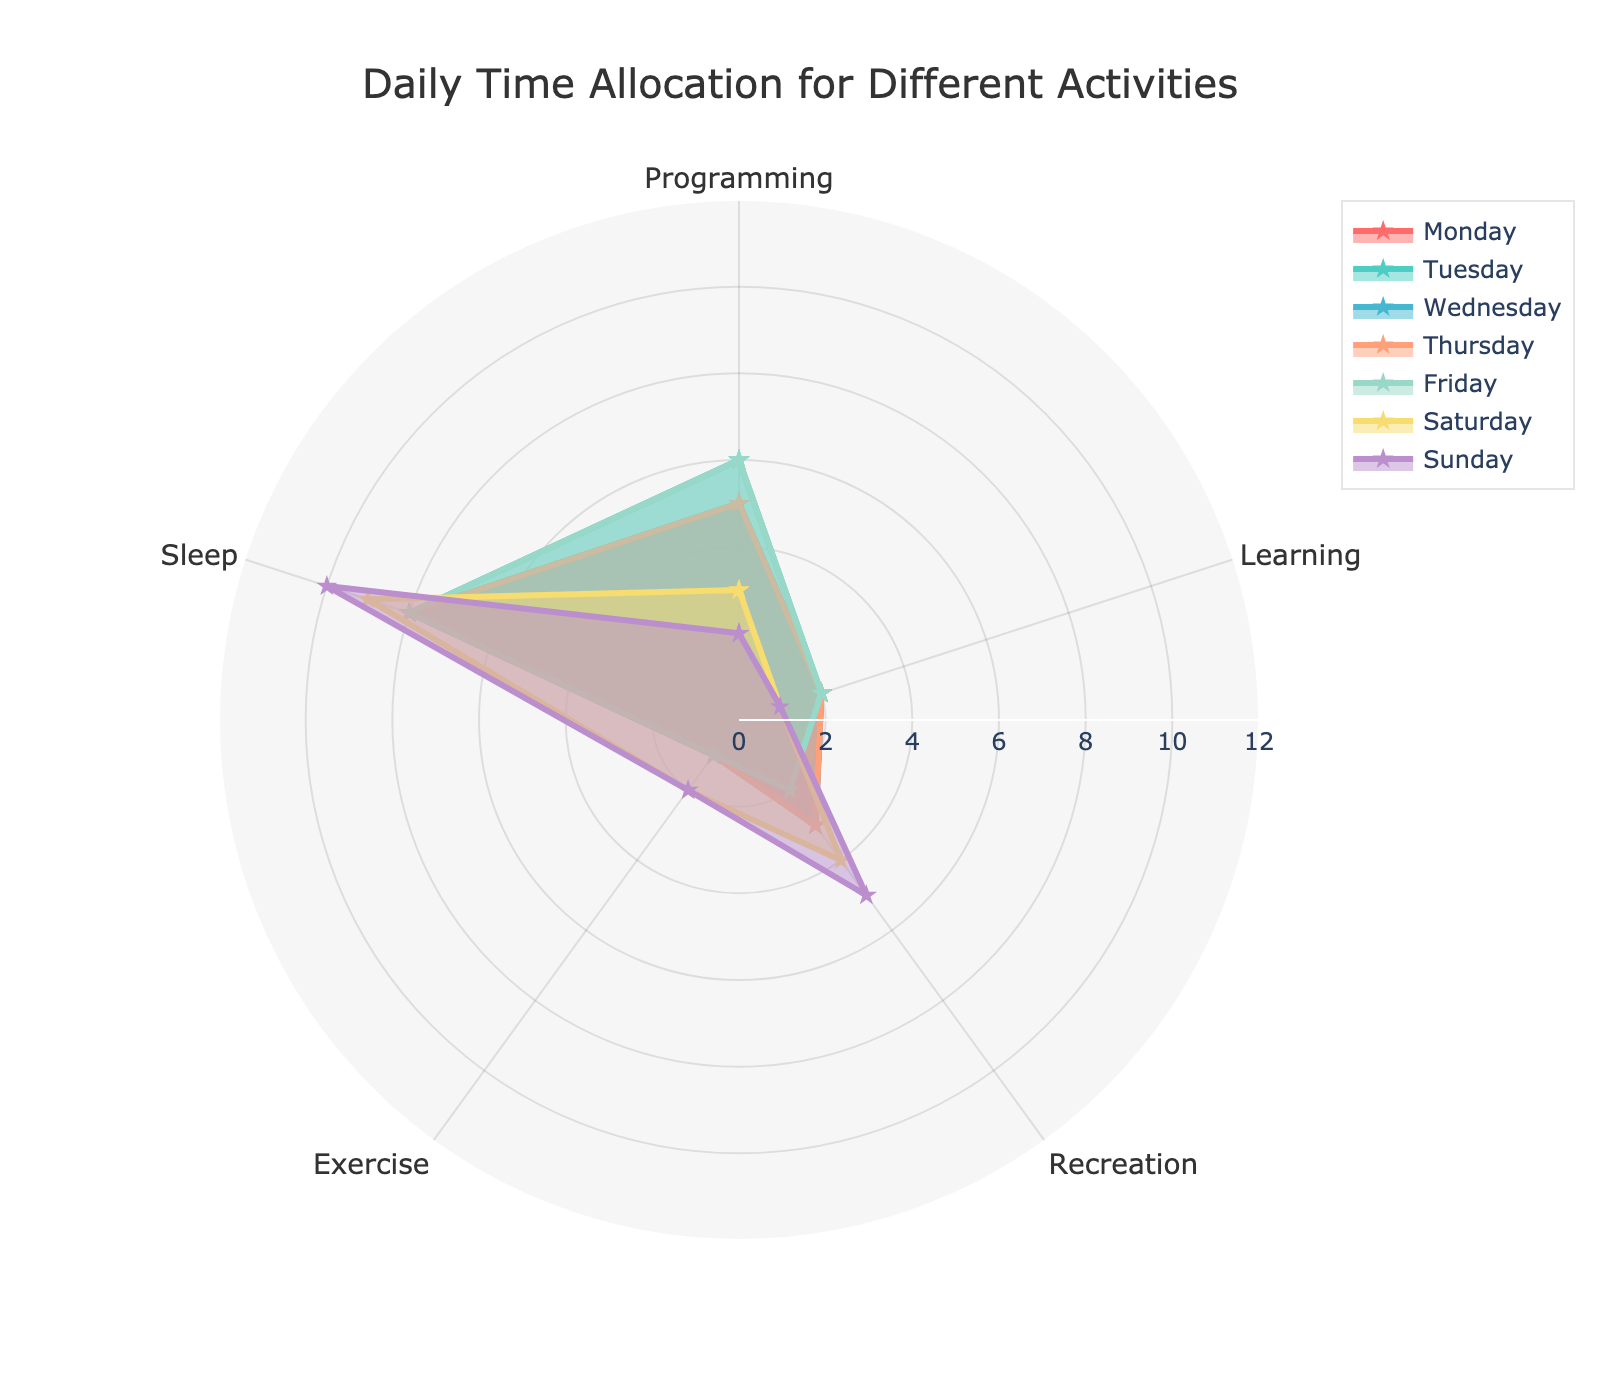What is the title of the radar chart? The title is located at the top of the radar chart and indicates what the chart is about.
Answer: Daily Time Allocation for Different Activities How many hours are allocated to exercise on Saturday compared to Sunday? Look at the sections for 'Exercise' on both Saturday and Sunday. Saturday shows 2 hours and Sunday also shows 2 hours.
Answer: Equal (2 hours) Which day shows the highest allocation for sleep? Find the highest point on the 'Sleep' axis for all days. Sunday shows the highest value at 10 hours.
Answer: Sunday What is the total time spent on learning across all days? Sum the hours dedicated to learning from Monday to Sunday: 2 + 2 + 2 + 2 + 2 + 1 + 1.
Answer: 12 hours For which activity is the time allocation the most consistent across all days? Consistency is indicated by minimal variation in the values. 'Learning' has a consistent allocation of 2 hours for weekdays and only slightly reduces to 1 hour on weekends.
Answer: Learning Compare the time spent on programming on weekdays (Monday to Friday) to weekends (Saturday and Sunday). What is the difference? Sum the hours for programming on weekdays: 5 + 6 + 5 + 5 + 6 = 27. For weekends: 3 + 2 = 5. The difference is 27 - 5.
Answer: 22 hours How does the time allocated to recreation on Wednesday compare to Monday? Look at the 'Recreation' values for Monday (3 hours) and Wednesday (3 hours). Both are equal.
Answer: Equal (3 hours) Which day has the least time allocated to programming? The smallest value in the 'Programming' section across all days is Sunday with 2 hours.
Answer: Sunday Which day has the highest combined time of exercise and recreation? Add the hours of exercise and recreation for each day and compare: 
- Monday: 1 + 3 = 4
- Tuesday: 1 + 2 = 3
- Wednesday: 1 + 3 = 4
- Thursday: 1 + 3 = 4
- Friday: 1 + 2 = 3
- Saturday: 2 + 4 = 6
- Sunday: 2 + 5 = 7. Sunday has the highest combined time.
Answer: Sunday 